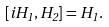<formula> <loc_0><loc_0><loc_500><loc_500>\left [ i H _ { 1 } , H _ { 2 } \right ] = H _ { 1 } .</formula> 